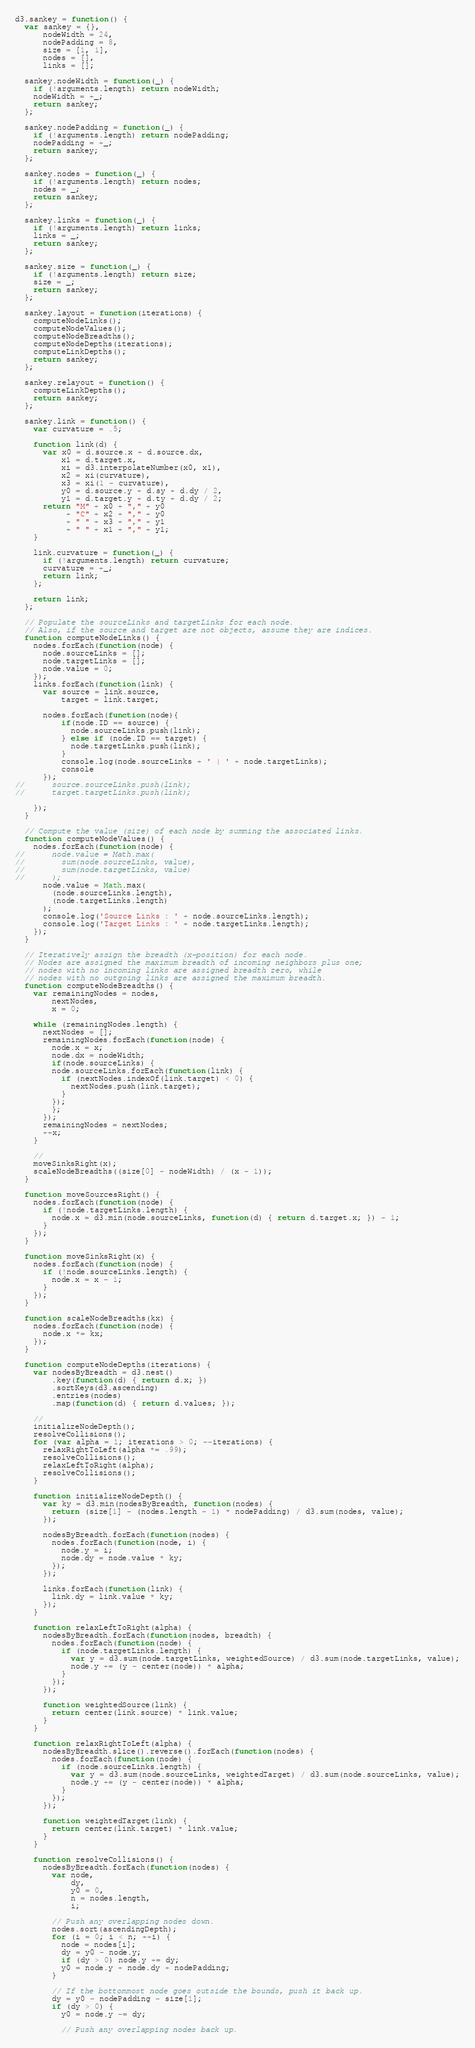Convert code to text. <code><loc_0><loc_0><loc_500><loc_500><_JavaScript_>d3.sankey = function() {
  var sankey = {},
      nodeWidth = 24,
      nodePadding = 8,
      size = [1, 1],
      nodes = [],
      links = [];

  sankey.nodeWidth = function(_) {
    if (!arguments.length) return nodeWidth;
    nodeWidth = +_;
    return sankey;
  };

  sankey.nodePadding = function(_) {
    if (!arguments.length) return nodePadding;
    nodePadding = +_;
    return sankey;
  };

  sankey.nodes = function(_) {
    if (!arguments.length) return nodes;
    nodes = _;
    return sankey;
  };

  sankey.links = function(_) {
    if (!arguments.length) return links;
    links = _;
    return sankey;
  };

  sankey.size = function(_) {
    if (!arguments.length) return size;
    size = _;
    return sankey;
  };

  sankey.layout = function(iterations) {
    computeNodeLinks();
    computeNodeValues();
    computeNodeBreadths();
    computeNodeDepths(iterations);
    computeLinkDepths();
    return sankey;
  };

  sankey.relayout = function() {
    computeLinkDepths();
    return sankey;
  };

  sankey.link = function() {
    var curvature = .5;

    function link(d) {
      var x0 = d.source.x + d.source.dx,
          x1 = d.target.x,
          xi = d3.interpolateNumber(x0, x1),
          x2 = xi(curvature),
          x3 = xi(1 - curvature),
          y0 = d.source.y + d.sy + d.dy / 2,
          y1 = d.target.y + d.ty + d.dy / 2;
      return "M" + x0 + "," + y0
           + "C" + x2 + "," + y0
           + " " + x3 + "," + y1
           + " " + x1 + "," + y1;
    }

    link.curvature = function(_) {
      if (!arguments.length) return curvature;
      curvature = +_;
      return link;
    };

    return link;
  };

  // Populate the sourceLinks and targetLinks for each node.
  // Also, if the source and target are not objects, assume they are indices.
  function computeNodeLinks() {
    nodes.forEach(function(node) {
      node.sourceLinks = [];
      node.targetLinks = [];
	  node.value = 0;
    });
    links.forEach(function(link) {
      var source = link.source,
          target = link.target;

	  nodes.forEach(function(node){
		  if(node.ID == source) {
		  	node.sourceLinks.push(link);
		  } else if (node.ID == target) {
		  	node.targetLinks.push(link);
		  }
		  console.log(node.sourceLinks + ' | ' + node.targetLinks);
		  console
	  });
//      source.sourceLinks.push(link);
//      target.targetLinks.push(link);

    });
  }

  // Compute the value (size) of each node by summing the associated links.
  function computeNodeValues() {
    nodes.forEach(function(node) {
//      node.value = Math.max(
//        sum(node.sourceLinks, value),
//        sum(node.targetLinks, value)
//      );
      node.value = Math.max(
        (node.sourceLinks.length),
        (node.targetLinks.length)
      );
	  console.log('Source Links : ' + node.sourceLinks.length);
	  console.log('Target Links : ' + node.targetLinks.length);
    });
  }

  // Iteratively assign the breadth (x-position) for each node.
  // Nodes are assigned the maximum breadth of incoming neighbors plus one;
  // nodes with no incoming links are assigned breadth zero, while
  // nodes with no outgoing links are assigned the maximum breadth.
  function computeNodeBreadths() {
    var remainingNodes = nodes,
        nextNodes,
        x = 0;

    while (remainingNodes.length) {
      nextNodes = [];
      remainingNodes.forEach(function(node) {
        node.x = x;
        node.dx = nodeWidth;
		if(node.sourceLinks) {
        node.sourceLinks.forEach(function(link) {
          if (nextNodes.indexOf(link.target) < 0) {
            nextNodes.push(link.target);
          }
        });
		};
      });
      remainingNodes = nextNodes;
      ++x;
    }

    //
    moveSinksRight(x);
    scaleNodeBreadths((size[0] - nodeWidth) / (x - 1));
  }

  function moveSourcesRight() {
    nodes.forEach(function(node) {
      if (!node.targetLinks.length) {
        node.x = d3.min(node.sourceLinks, function(d) { return d.target.x; }) - 1;
      }
    });
  }

  function moveSinksRight(x) {
    nodes.forEach(function(node) {
      if (!node.sourceLinks.length) {
        node.x = x - 1;
      }
    });
  }

  function scaleNodeBreadths(kx) {
    nodes.forEach(function(node) {
      node.x *= kx;
    });
  }

  function computeNodeDepths(iterations) {
    var nodesByBreadth = d3.nest()
        .key(function(d) { return d.x; })
        .sortKeys(d3.ascending)
        .entries(nodes)
        .map(function(d) { return d.values; });

    //
    initializeNodeDepth();
    resolveCollisions();
    for (var alpha = 1; iterations > 0; --iterations) {
      relaxRightToLeft(alpha *= .99);
      resolveCollisions();
      relaxLeftToRight(alpha);
      resolveCollisions();
    }

    function initializeNodeDepth() {
      var ky = d3.min(nodesByBreadth, function(nodes) {
        return (size[1] - (nodes.length - 1) * nodePadding) / d3.sum(nodes, value);
      });

      nodesByBreadth.forEach(function(nodes) {
        nodes.forEach(function(node, i) {
          node.y = i;
          node.dy = node.value * ky;
        });
      });

      links.forEach(function(link) {
        link.dy = link.value * ky;
      });
    }

    function relaxLeftToRight(alpha) {
      nodesByBreadth.forEach(function(nodes, breadth) {
        nodes.forEach(function(node) {
          if (node.targetLinks.length) {
            var y = d3.sum(node.targetLinks, weightedSource) / d3.sum(node.targetLinks, value);
            node.y += (y - center(node)) * alpha;
          }
        });
      });

      function weightedSource(link) {
        return center(link.source) * link.value;
      }
    }

    function relaxRightToLeft(alpha) {
      nodesByBreadth.slice().reverse().forEach(function(nodes) {
        nodes.forEach(function(node) {
          if (node.sourceLinks.length) {
            var y = d3.sum(node.sourceLinks, weightedTarget) / d3.sum(node.sourceLinks, value);
            node.y += (y - center(node)) * alpha;
          }
        });
      });

      function weightedTarget(link) {
        return center(link.target) * link.value;
      }
    }

    function resolveCollisions() {
      nodesByBreadth.forEach(function(nodes) {
        var node,
            dy,
            y0 = 0,
            n = nodes.length,
            i;

        // Push any overlapping nodes down.
        nodes.sort(ascendingDepth);
        for (i = 0; i < n; ++i) {
          node = nodes[i];
          dy = y0 - node.y;
          if (dy > 0) node.y += dy;
          y0 = node.y + node.dy + nodePadding;
        }

        // If the bottommost node goes outside the bounds, push it back up.
        dy = y0 - nodePadding - size[1];
        if (dy > 0) {
          y0 = node.y -= dy;

          // Push any overlapping nodes back up.</code> 